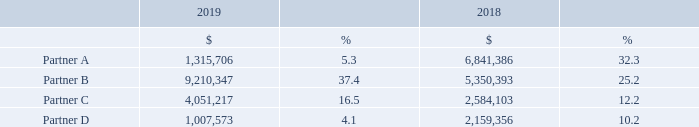NOTE 14 – MAJOR CUSTOMERS AND VENDORS (CONTINUED)
Our accounts receivable includes 3 customers that individually make up more than 10% of our accounts receivable at December 31, 2019 in the percentages of 17.8%, 15.4% and 13.3%.
The Company had four key partners through which 10% or greater of its revenue was generated in either 2019 or 2018 as set forth below. The amounts in the table below reflect the amount of revenue generated through those customers.
How many key partners that the Company had which 10% or greater of its revenue was generated in either 2019 or 2018? Four. What are the amounts of revenue generated from Partner B in 2018 and 2019, respectively? 5,350,393, 9,210,347. What are the amounts of revenue generated from Partner A in 2018 and 2019, respectively? 6,841,386, 1,315,706. What is the percentage change in revenue generated from Partner C from 2018 to 2019?
Answer scale should be: percent. (4,051,217-2,584,103)/2,584,103 
Answer: 56.77. Which partner contributed the highest revenue to the Company in 2018? 6,841,386>5,350,393>2,584,103>2,159,356
Answer: partner a. What is the average revenue generated from Partner D in the last 2 years, i.e. 2018 and 2019? (1,007,573+2,159,356)/2 
Answer: 1583464.5. 